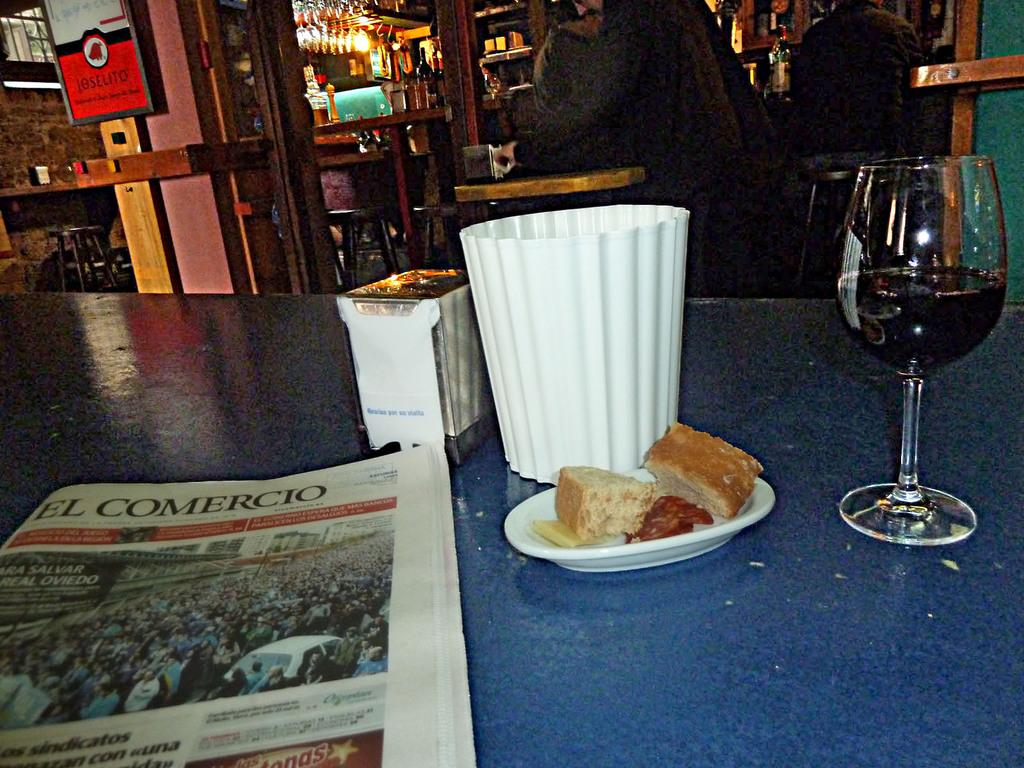Provide a one-sentence caption for the provided image. A half full wine glass sits on a table along with a paper from El Comercio. 